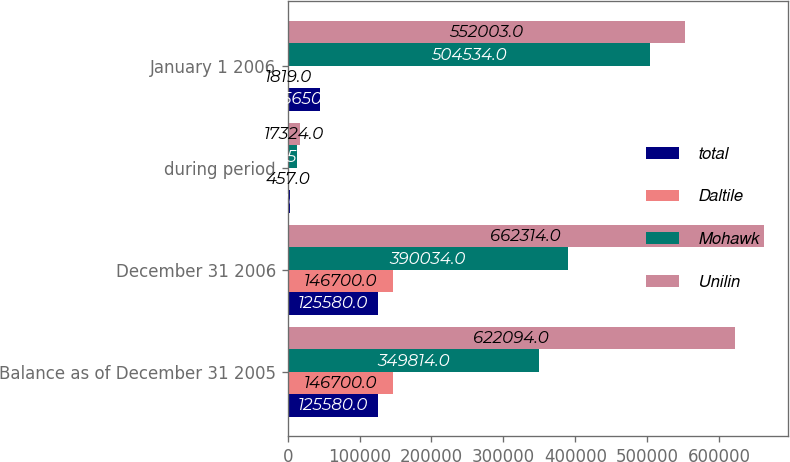Convert chart. <chart><loc_0><loc_0><loc_500><loc_500><stacked_bar_chart><ecel><fcel>Balance as of December 31 2005<fcel>December 31 2006<fcel>during period<fcel>January 1 2006<nl><fcel>total<fcel>125580<fcel>125580<fcel>3610<fcel>45650<nl><fcel>Daltile<fcel>146700<fcel>146700<fcel>457<fcel>1819<nl><fcel>Mohawk<fcel>349814<fcel>390034<fcel>13257<fcel>504534<nl><fcel>Unilin<fcel>622094<fcel>662314<fcel>17324<fcel>552003<nl></chart> 